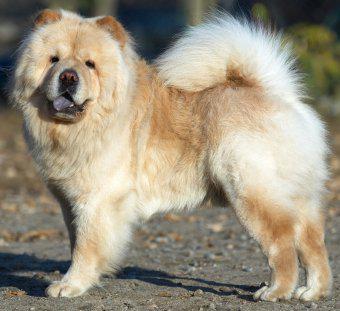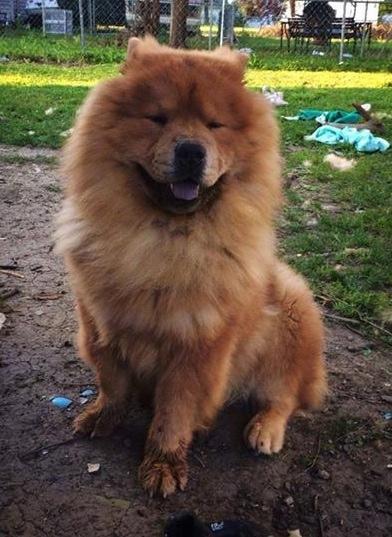The first image is the image on the left, the second image is the image on the right. Assess this claim about the two images: "There is exactly one dog in the right image.". Correct or not? Answer yes or no. Yes. The first image is the image on the left, the second image is the image on the right. For the images displayed, is the sentence "A chow dog with its blue tongue showing is standing on all fours with its body in profile." factually correct? Answer yes or no. Yes. 